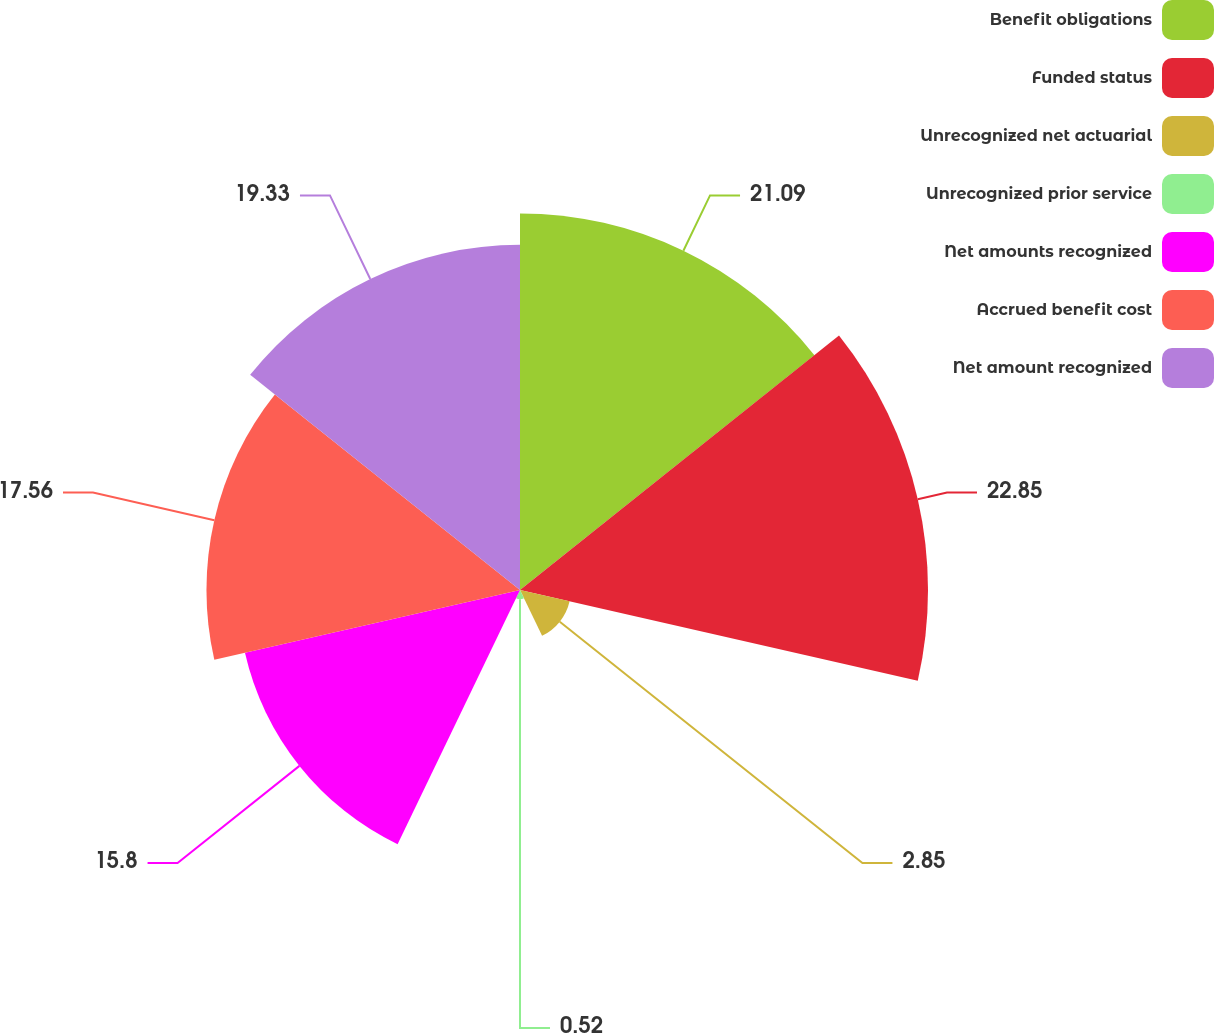<chart> <loc_0><loc_0><loc_500><loc_500><pie_chart><fcel>Benefit obligations<fcel>Funded status<fcel>Unrecognized net actuarial<fcel>Unrecognized prior service<fcel>Net amounts recognized<fcel>Accrued benefit cost<fcel>Net amount recognized<nl><fcel>21.09%<fcel>22.85%<fcel>2.85%<fcel>0.52%<fcel>15.8%<fcel>17.56%<fcel>19.33%<nl></chart> 